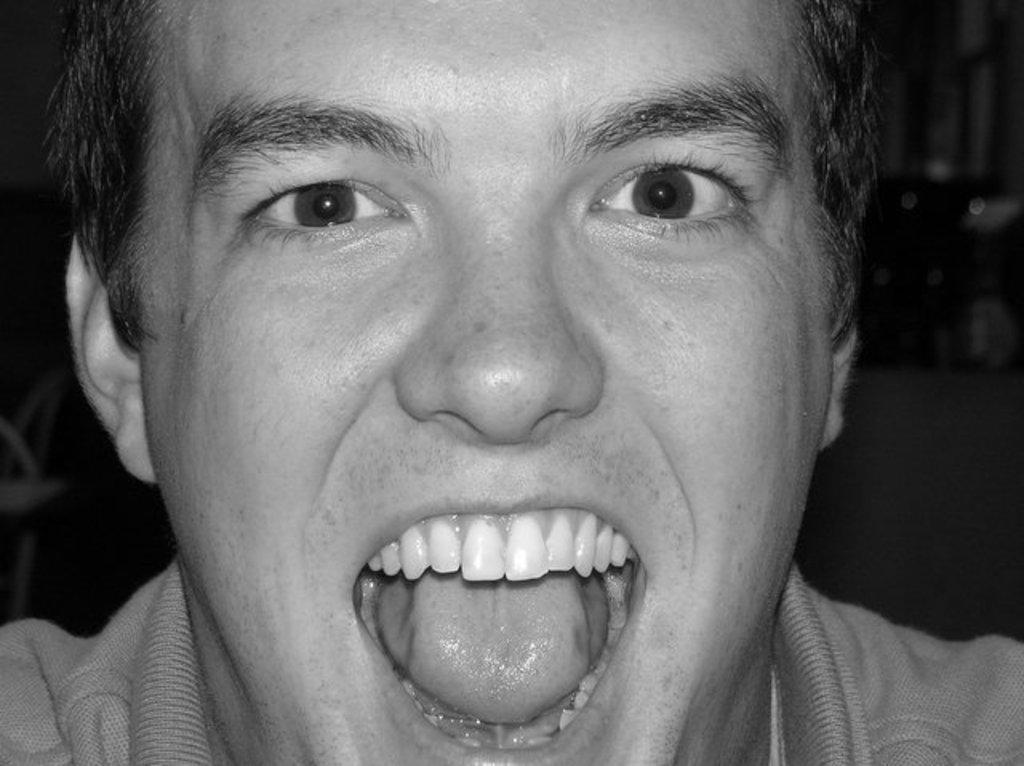What is the color scheme of the image? The image is black and white. What can be seen in the foreground of the image? There is a person's head in the image. How is the background of the image depicted? The background behind the person is blurred. What news story is being discussed by the person in the image? There is no indication of a news story or discussion in the image, as it only shows a person's head with a blurred background. 